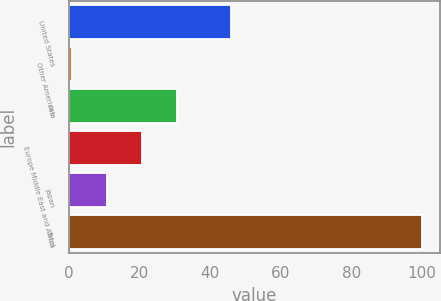Convert chart to OTSL. <chart><loc_0><loc_0><loc_500><loc_500><bar_chart><fcel>United States<fcel>Other Americas<fcel>Asia<fcel>Europe Middle East and Africa<fcel>Japan<fcel>Total<nl><fcel>46<fcel>1<fcel>30.7<fcel>20.8<fcel>10.9<fcel>100<nl></chart> 